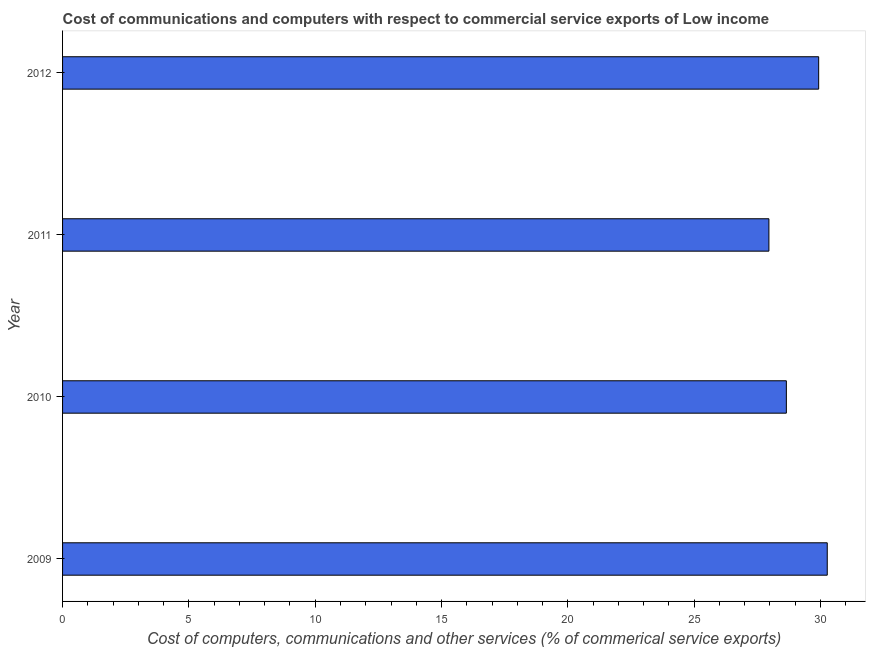Does the graph contain any zero values?
Your answer should be very brief. No. What is the title of the graph?
Offer a very short reply. Cost of communications and computers with respect to commercial service exports of Low income. What is the label or title of the X-axis?
Offer a very short reply. Cost of computers, communications and other services (% of commerical service exports). What is the label or title of the Y-axis?
Give a very brief answer. Year. What is the cost of communications in 2010?
Keep it short and to the point. 28.65. Across all years, what is the maximum cost of communications?
Your answer should be very brief. 30.27. Across all years, what is the minimum cost of communications?
Offer a terse response. 27.96. What is the sum of the cost of communications?
Provide a short and direct response. 116.8. What is the difference between the cost of communications in 2009 and 2011?
Provide a short and direct response. 2.31. What is the average  computer and other services per year?
Your answer should be compact. 29.2. What is the median  computer and other services?
Provide a short and direct response. 29.29. What is the ratio of the cost of communications in 2011 to that in 2012?
Offer a very short reply. 0.93. What is the difference between the highest and the second highest  computer and other services?
Give a very brief answer. 0.34. What is the difference between the highest and the lowest cost of communications?
Give a very brief answer. 2.31. How many bars are there?
Your response must be concise. 4. How many years are there in the graph?
Give a very brief answer. 4. Are the values on the major ticks of X-axis written in scientific E-notation?
Provide a succinct answer. No. What is the Cost of computers, communications and other services (% of commerical service exports) in 2009?
Make the answer very short. 30.27. What is the Cost of computers, communications and other services (% of commerical service exports) in 2010?
Your answer should be compact. 28.65. What is the Cost of computers, communications and other services (% of commerical service exports) in 2011?
Your answer should be compact. 27.96. What is the Cost of computers, communications and other services (% of commerical service exports) in 2012?
Offer a very short reply. 29.93. What is the difference between the Cost of computers, communications and other services (% of commerical service exports) in 2009 and 2010?
Your answer should be compact. 1.62. What is the difference between the Cost of computers, communications and other services (% of commerical service exports) in 2009 and 2011?
Give a very brief answer. 2.31. What is the difference between the Cost of computers, communications and other services (% of commerical service exports) in 2009 and 2012?
Give a very brief answer. 0.34. What is the difference between the Cost of computers, communications and other services (% of commerical service exports) in 2010 and 2011?
Offer a terse response. 0.69. What is the difference between the Cost of computers, communications and other services (% of commerical service exports) in 2010 and 2012?
Provide a succinct answer. -1.28. What is the difference between the Cost of computers, communications and other services (% of commerical service exports) in 2011 and 2012?
Your response must be concise. -1.97. What is the ratio of the Cost of computers, communications and other services (% of commerical service exports) in 2009 to that in 2010?
Provide a short and direct response. 1.06. What is the ratio of the Cost of computers, communications and other services (% of commerical service exports) in 2009 to that in 2011?
Your answer should be compact. 1.08. What is the ratio of the Cost of computers, communications and other services (% of commerical service exports) in 2009 to that in 2012?
Your answer should be compact. 1.01. What is the ratio of the Cost of computers, communications and other services (% of commerical service exports) in 2010 to that in 2011?
Make the answer very short. 1.02. What is the ratio of the Cost of computers, communications and other services (% of commerical service exports) in 2011 to that in 2012?
Offer a very short reply. 0.93. 